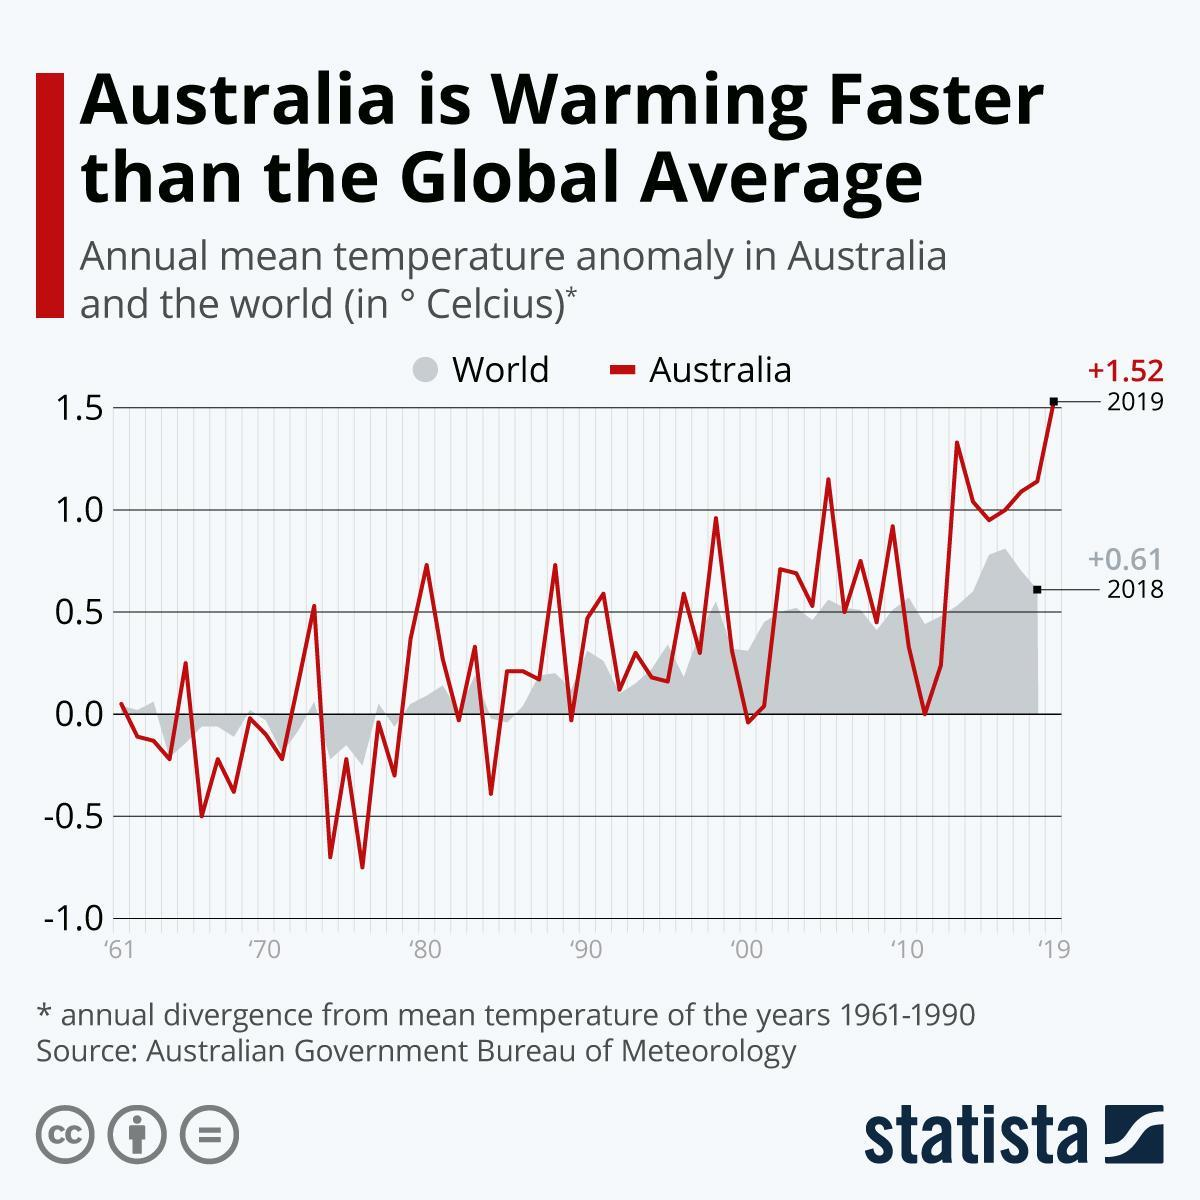When did the temperature anomaly in Australia take place?
Answer the question with a short phrase. 2019 What was the highest annual mean temperature in the world in degree celcius? +0.61 What was the highest annual mean temperature in Australia in degree celcius? +1.52 